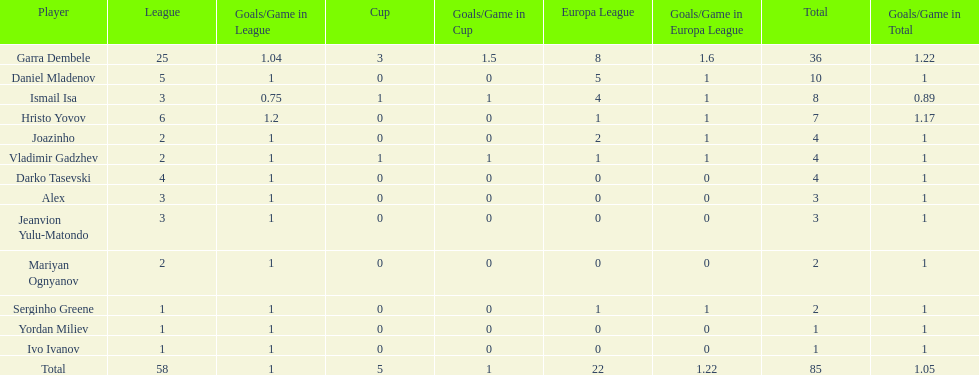Who had the most goal scores? Garra Dembele. 